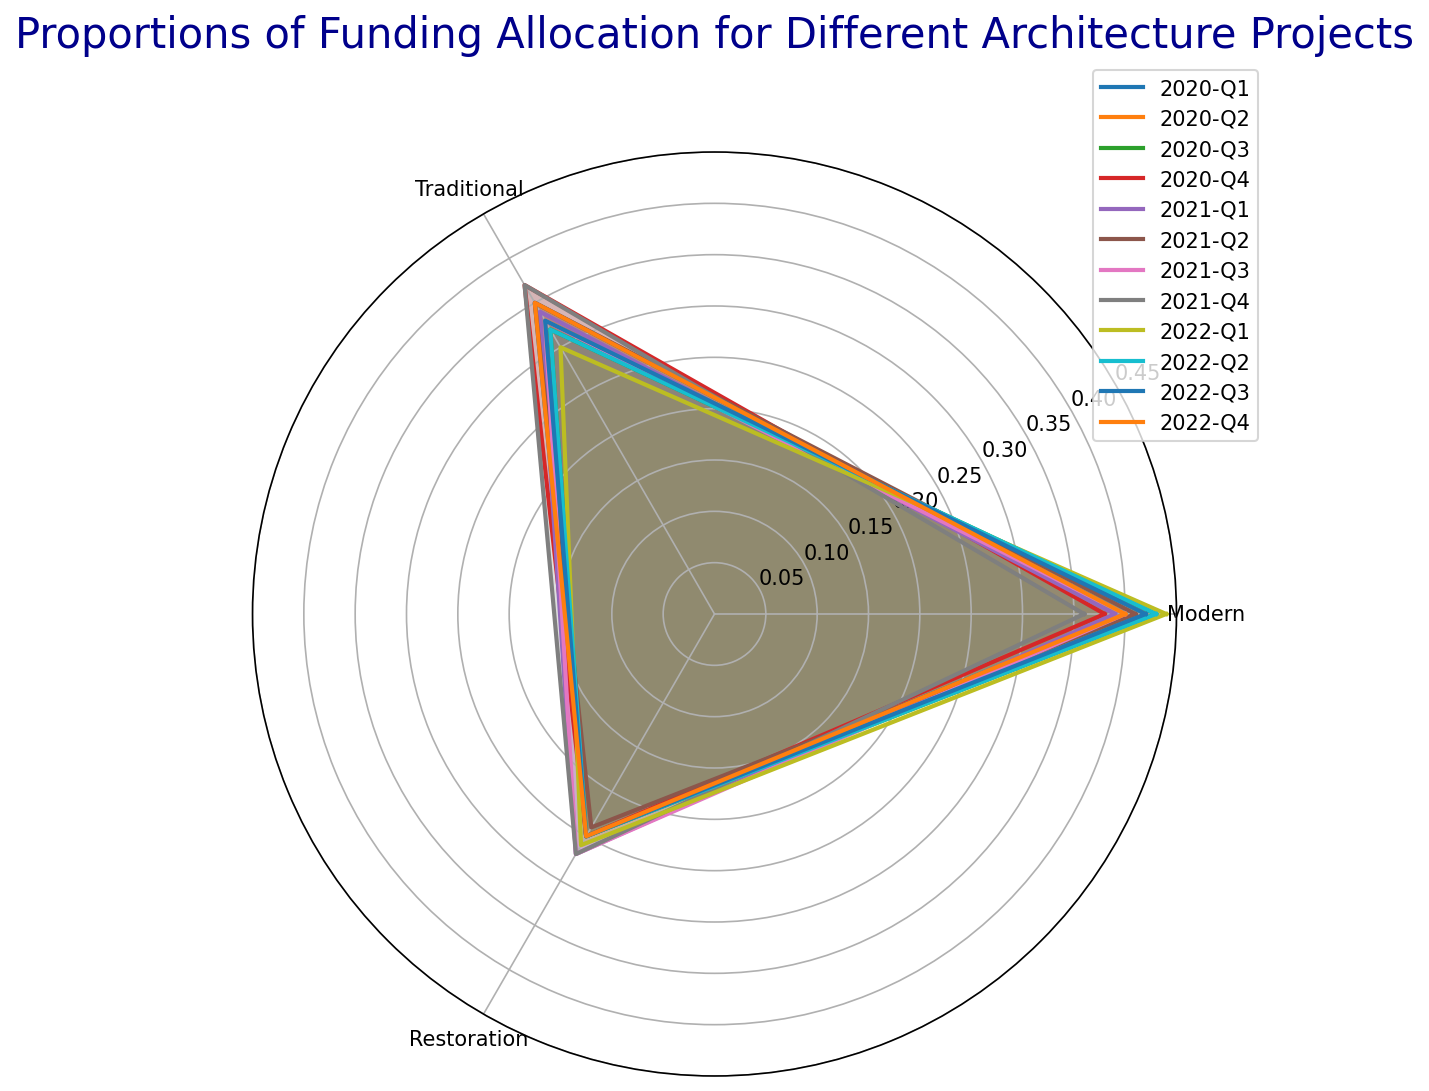What is the highest proportion of funding allocated to Modern architecture, and in which quarter did it occur? The radar chart shows the quarterly proportions of funding allocations. By examining the chart, the highest proportion for Modern architecture is at 0.44, which occurs in 2022-Q1
Answer: 0.44 in 2022-Q1 Which quarter has the lowest proportion of funding for Traditional architecture? Observing the chart, we look for the smallest value in the Traditional category. The lowest proportion is 0.30, occurring in 2022-Q1
Answer: 2022-Q1 What are the average quarterly funding proportions for Restoration architecture across the years observed? The proportions for Restoration architecture are relatively stable. Summing the proportions (0.25+0.25+0.25+0.25+0.27+0.24+0.27+0.27+0.26+0.25+0.25+0.25) gives 3.06. Dividing by 12 (the number of quarters) provides the average of 0.255
Answer: 0.255 In which quarter is the variance between the highest and lowest proportions across the three categories the smallest? To find the minimum variance, we calculate the differences between the highest and lowest proportions for each quarter. Summarizing, 2021-Q1 (0.39-0.27=0.12) has the smallest variance among quarters
Answer: 2021-Q1 Is there any quarter where the proportion of funding for Traditional architecture exceeded Modern architecture? By visually inspecting the radar chart, we find that in no quarter does Traditional architecture's proportion exceeds Modern's. The closest is 2020-Q4, but Traditional is still slightly lower.
Answer: No How does the funding allocation for Traditional architecture trend over the observed periods? Examining the chart, Traditional funding initially declines from 0.35 to a low of 0.32 and fluctuates slightly up and down, peaking occasionally before holding at 0.35
Answer: Declining then fluctuating On average, which type of architecture received the greatest proportion of funding? To compare averages, calculate the average proportions for Modern (sum 4.87/12 = 0.4058), Traditional (sum 4.06/12 = 0.3383), and Restoration (sum 3.06/12 = 0.255). Modern architecture averages the highest proportion.
Answer: Modern 